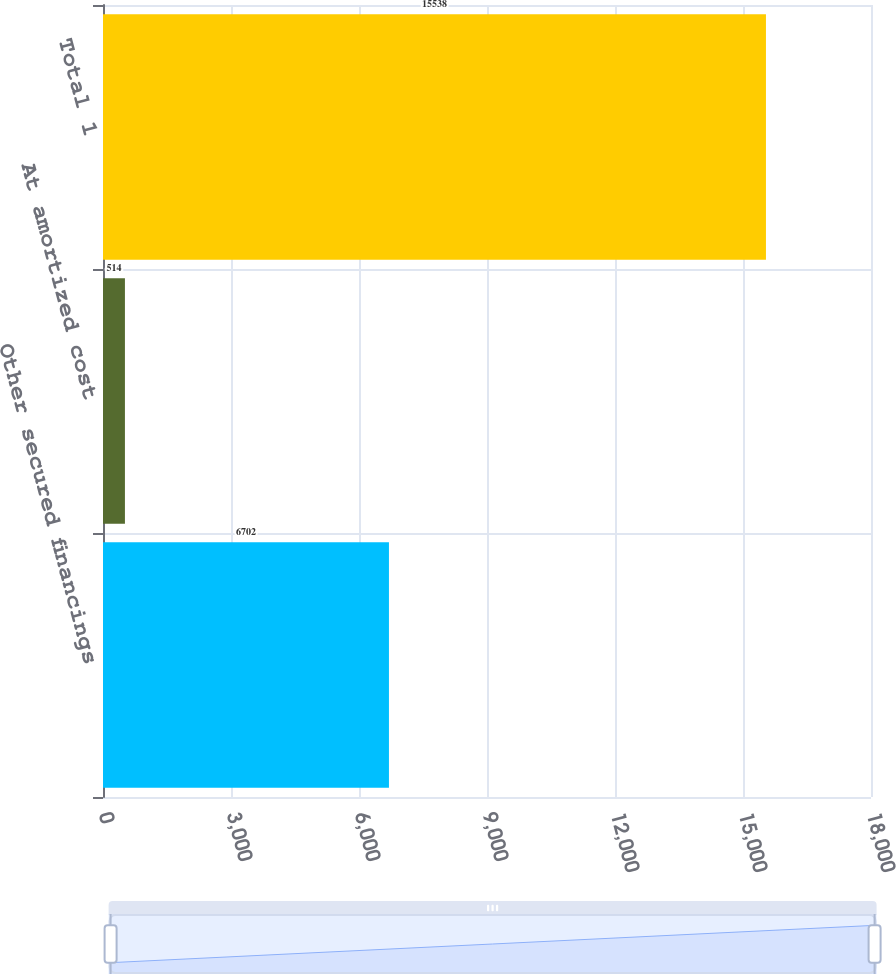Convert chart. <chart><loc_0><loc_0><loc_500><loc_500><bar_chart><fcel>Other secured financings<fcel>At amortized cost<fcel>Total 1<nl><fcel>6702<fcel>514<fcel>15538<nl></chart> 